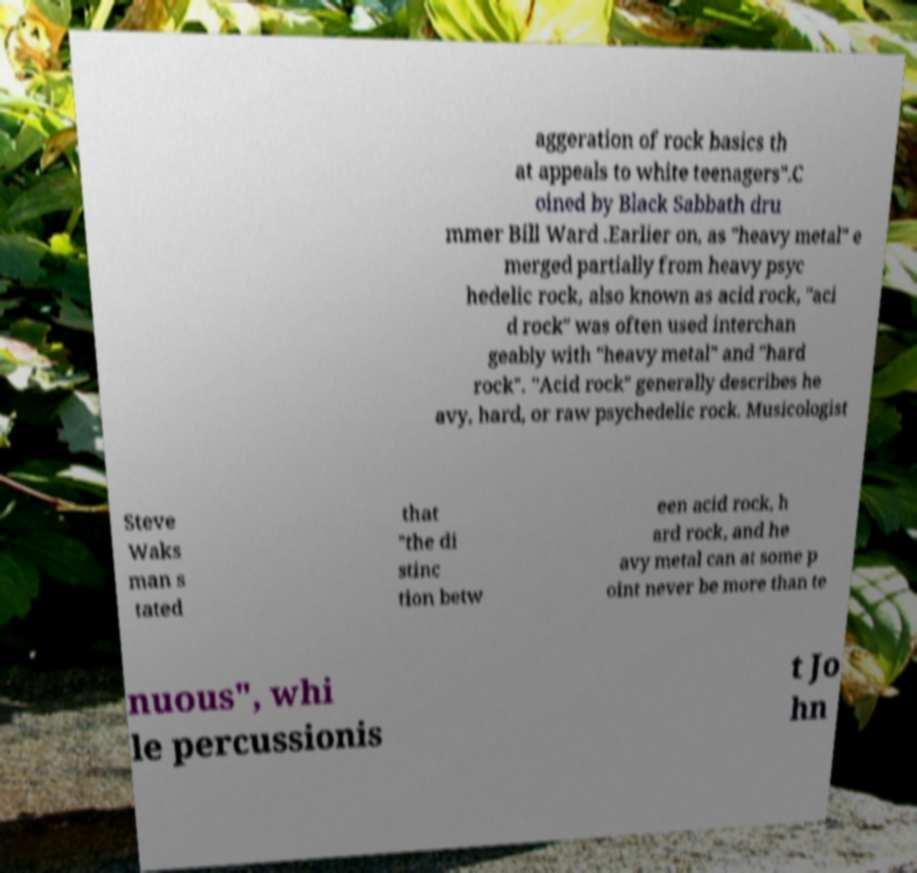Please identify and transcribe the text found in this image. aggeration of rock basics th at appeals to white teenagers".C oined by Black Sabbath dru mmer Bill Ward .Earlier on, as "heavy metal" e merged partially from heavy psyc hedelic rock, also known as acid rock, "aci d rock" was often used interchan geably with "heavy metal" and "hard rock". "Acid rock" generally describes he avy, hard, or raw psychedelic rock. Musicologist Steve Waks man s tated that "the di stinc tion betw een acid rock, h ard rock, and he avy metal can at some p oint never be more than te nuous", whi le percussionis t Jo hn 